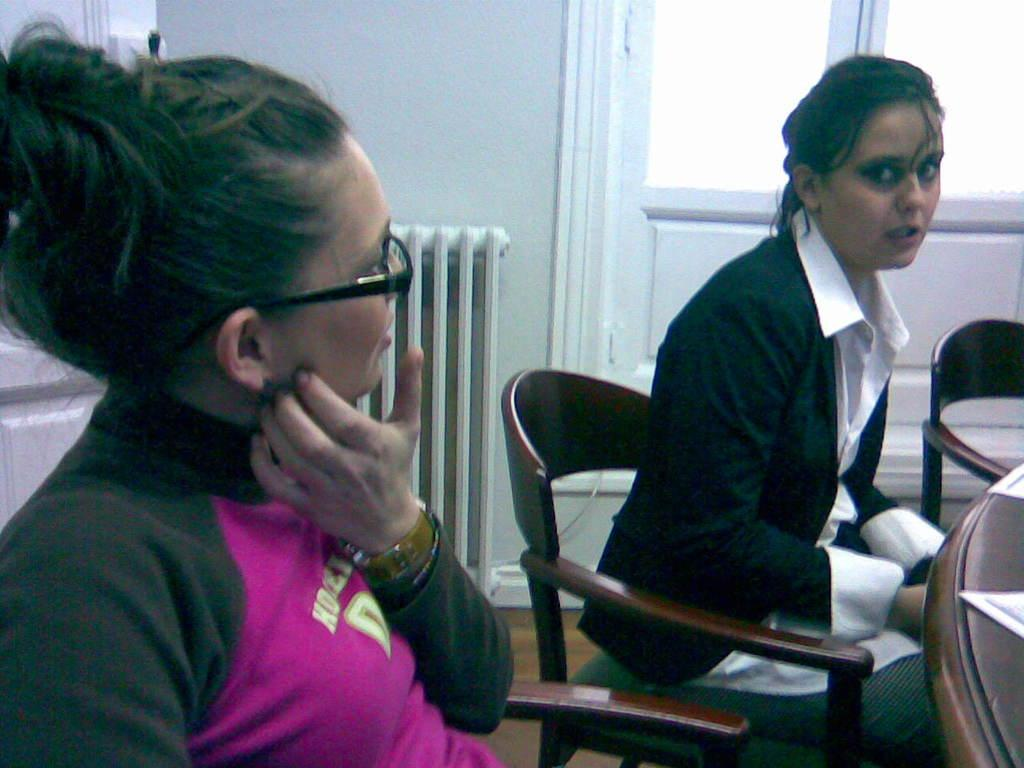How many people are in the image? There are two women in the image. What are the women doing in the image? The women are sitting on chairs. What is in front of the women? There is a table in front of the women. What can be seen in the background of the image? There is a wall in the background of the image. Is there any entrance or exit visible in the image? Yes, there is a door in the wall. What type of lamp is on the throne in the image? There is no lamp or throne present in the image. How does the door turn in the image? The door does not turn in the image; it is stationary within the wall. 